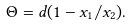Convert formula to latex. <formula><loc_0><loc_0><loc_500><loc_500>\Theta = d ( 1 - x _ { 1 } / x _ { 2 } ) .</formula> 